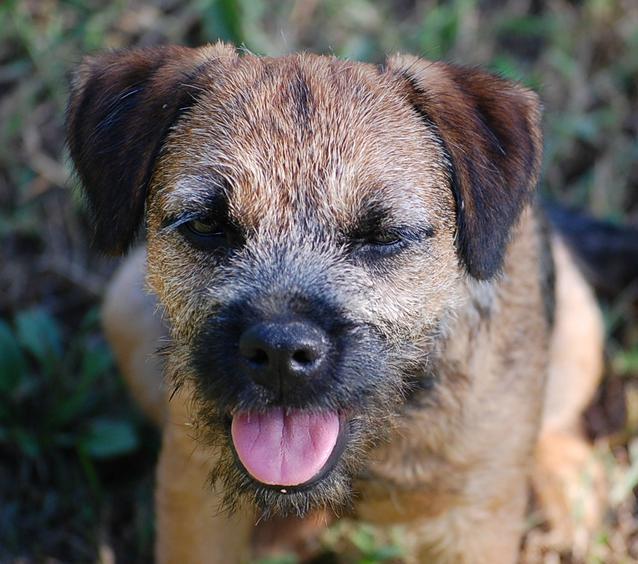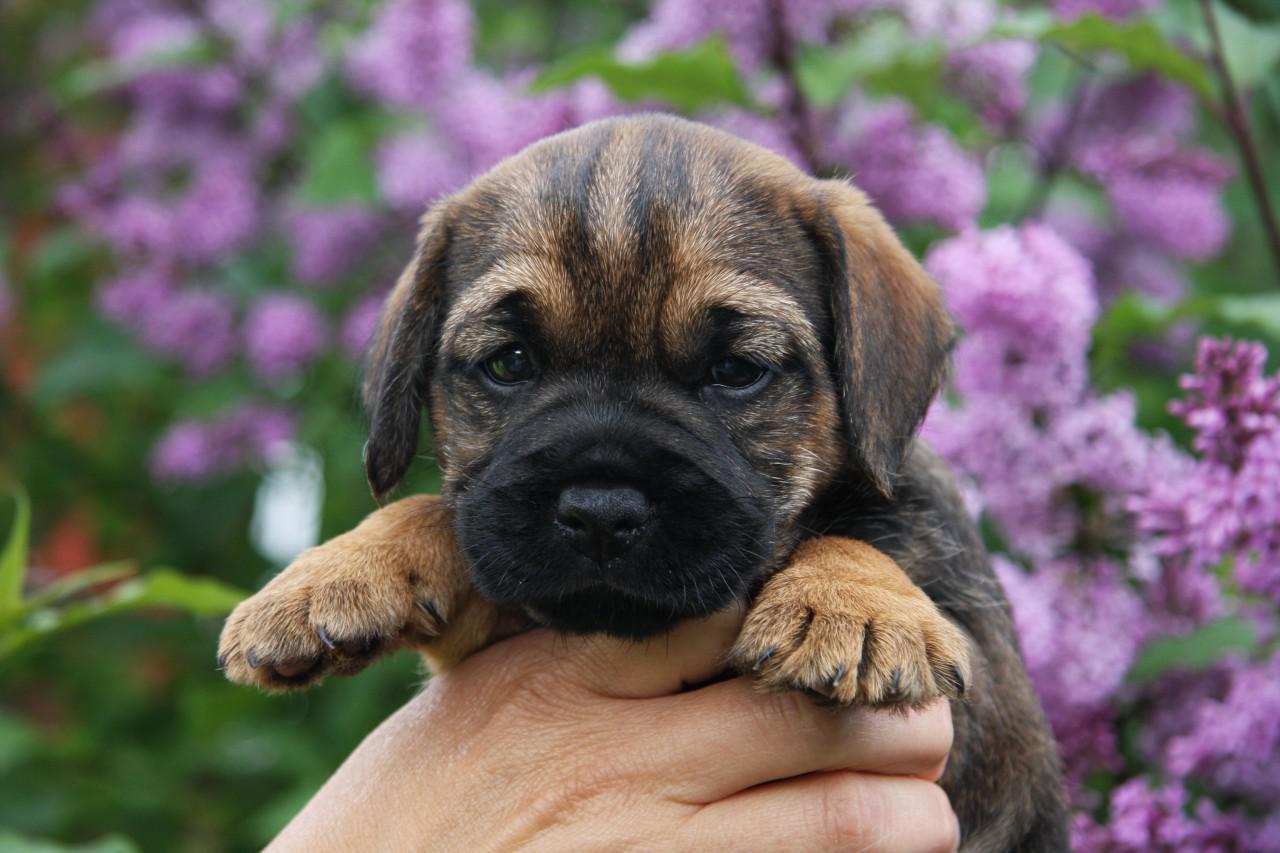The first image is the image on the left, the second image is the image on the right. Given the left and right images, does the statement "There are purple flowers behind the dog in one of the images but not the other." hold true? Answer yes or no. Yes. The first image is the image on the left, the second image is the image on the right. Considering the images on both sides, is "The collar on the dog in the right image, it is clearly visible." valid? Answer yes or no. No. 